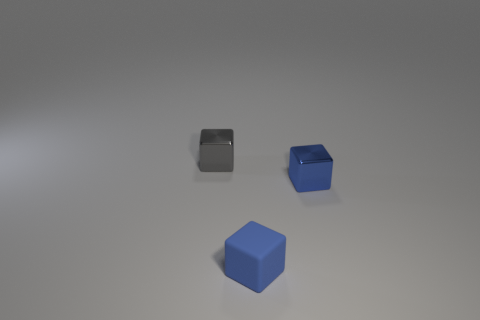There is another small thing that is the same color as the rubber thing; what is its material?
Provide a succinct answer. Metal. What color is the small object that is the same material as the tiny gray block?
Your response must be concise. Blue. Is there another blue block of the same size as the blue shiny block?
Provide a succinct answer. Yes. There is a small thing on the right side of the small matte thing; does it have the same color as the small rubber block?
Your answer should be compact. Yes. What is the color of the small thing that is both right of the gray metallic thing and behind the blue matte object?
Give a very brief answer. Blue. Is there a cyan matte object of the same shape as the gray object?
Provide a short and direct response. No. Do the metal cube on the right side of the gray metal thing and the small gray thing have the same size?
Make the answer very short. Yes. There is a cube that is both behind the blue matte block and in front of the small gray thing; how big is it?
Make the answer very short. Small. What is the size of the gray shiny object behind the tiny matte thing?
Your answer should be compact. Small. What number of big things are gray things or purple cylinders?
Give a very brief answer. 0. 